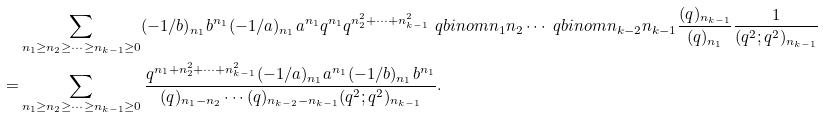<formula> <loc_0><loc_0><loc_500><loc_500>& \sum _ { n _ { 1 } \geq n _ { 2 } \geq \cdots \geq n _ { k - 1 } \geq 0 } ( - 1 / b ) _ { n _ { 1 } } b ^ { n _ { 1 } } ( - 1 / a ) _ { n _ { 1 } } a ^ { n _ { 1 } } q ^ { n _ { 1 } } q ^ { n _ { 2 } ^ { 2 } + \cdots + n _ { k - 1 } ^ { 2 } } \ q b i n o m { n _ { 1 } } { n _ { 2 } } \cdots \ q b i n o m { n _ { k - 2 } } { n _ { k - 1 } } \frac { ( q ) _ { n _ { k - 1 } } } { ( q ) _ { n _ { 1 } } } \frac { 1 } { ( q ^ { 2 } ; q ^ { 2 } ) _ { n _ { k - 1 } } } \\ = & \sum _ { n _ { 1 } \geq n _ { 2 } \geq \cdots \geq n _ { k - 1 } \geq 0 } \frac { q ^ { n _ { 1 } + n _ { 2 } ^ { 2 } + \cdots + n _ { k - 1 } ^ { 2 } } ( - 1 / a ) _ { n _ { 1 } } a ^ { n _ { 1 } } ( - 1 / b ) _ { n _ { 1 } } b ^ { n _ { 1 } } } { ( q ) _ { n _ { 1 } - n _ { 2 } } \cdots ( q ) _ { n _ { k - 2 } - n _ { k - 1 } } ( q ^ { 2 } ; q ^ { 2 } ) _ { n _ { k - 1 } } } .</formula> 